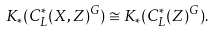<formula> <loc_0><loc_0><loc_500><loc_500>K _ { * } ( C ^ { * } _ { L } ( X , Z ) ^ { G } ) \cong K _ { * } ( C ^ { * } _ { L } ( Z ) ^ { G } ) .</formula> 